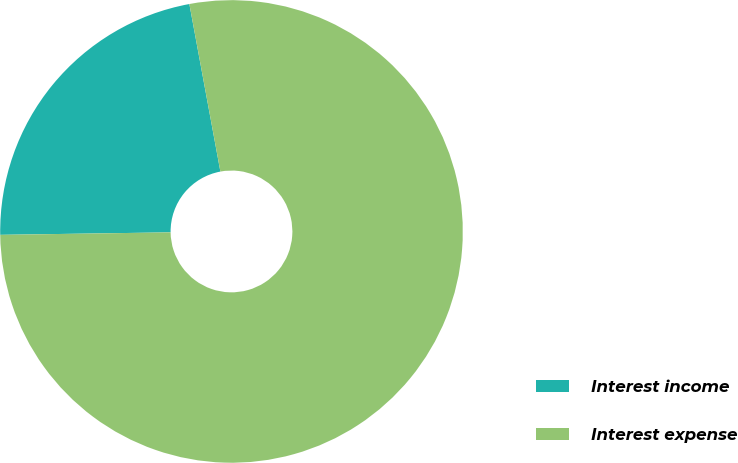Convert chart to OTSL. <chart><loc_0><loc_0><loc_500><loc_500><pie_chart><fcel>Interest income<fcel>Interest expense<nl><fcel>22.32%<fcel>77.68%<nl></chart> 